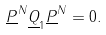<formula> <loc_0><loc_0><loc_500><loc_500>\underline { P } ^ { N } \underline { Q } _ { 1 } \underline { P } ^ { N } = 0 .</formula> 